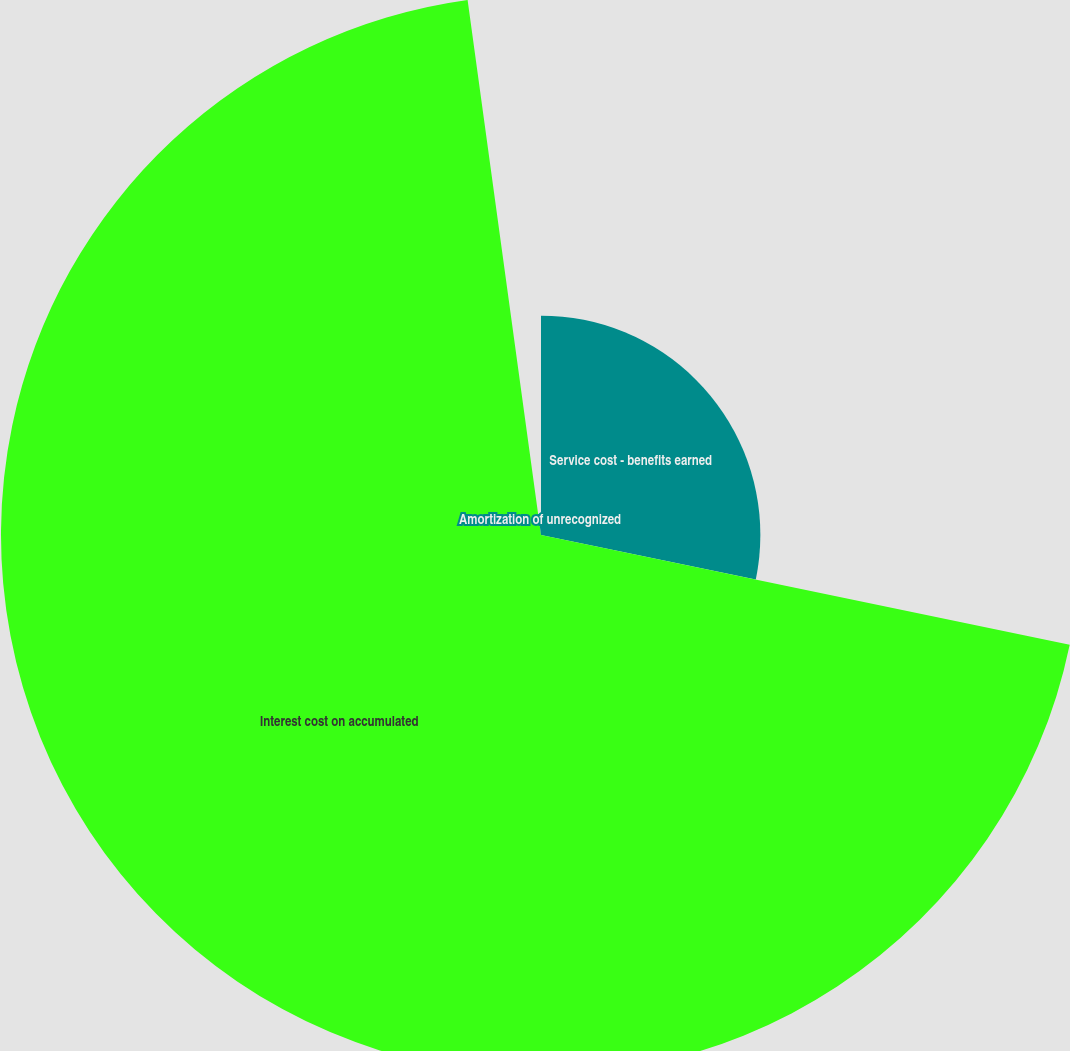Convert chart. <chart><loc_0><loc_0><loc_500><loc_500><pie_chart><fcel>Service cost - benefits earned<fcel>Interest cost on accumulated<fcel>Amortization of unrecognized<nl><fcel>28.26%<fcel>69.57%<fcel>2.17%<nl></chart> 